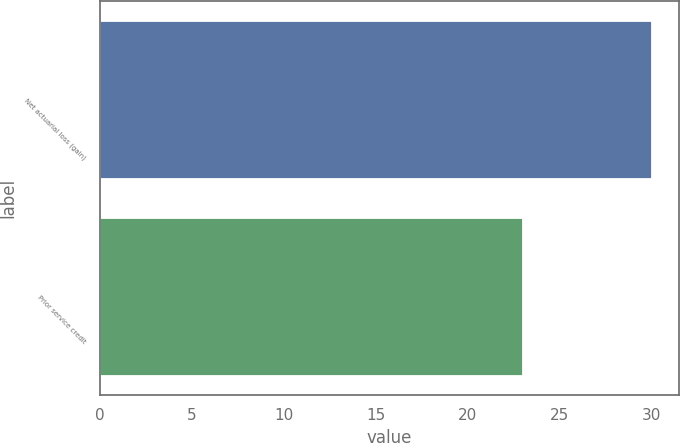Convert chart. <chart><loc_0><loc_0><loc_500><loc_500><bar_chart><fcel>Net actuarial loss (gain)<fcel>Prior service credit<nl><fcel>30<fcel>23<nl></chart> 